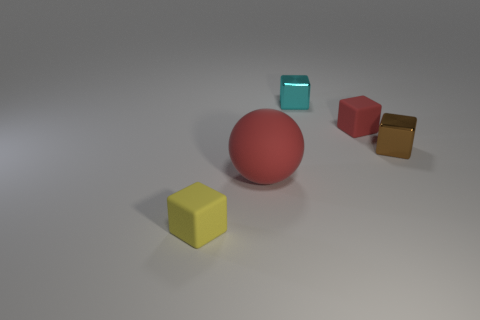The metallic cube right of the tiny rubber thing right of the tiny metallic cube to the left of the small red matte object is what color?
Keep it short and to the point. Brown. Is the large red sphere behind the yellow block made of the same material as the small thing that is in front of the big sphere?
Offer a very short reply. Yes. What shape is the small thing that is in front of the big thing?
Offer a terse response. Cube. What number of things are either large yellow rubber objects or shiny cubes that are behind the brown cube?
Offer a very short reply. 1. Does the brown object have the same material as the red ball?
Make the answer very short. No. Are there an equal number of tiny brown cubes in front of the big matte thing and big spheres behind the small brown shiny cube?
Make the answer very short. Yes. How many rubber things are to the right of the yellow thing?
Keep it short and to the point. 2. How many objects are either tiny red objects or brown metallic things?
Your answer should be very brief. 2. How many other brown blocks are the same size as the brown cube?
Provide a short and direct response. 0. There is a small rubber object that is in front of the red object behind the brown block; what is its shape?
Your answer should be compact. Cube. 